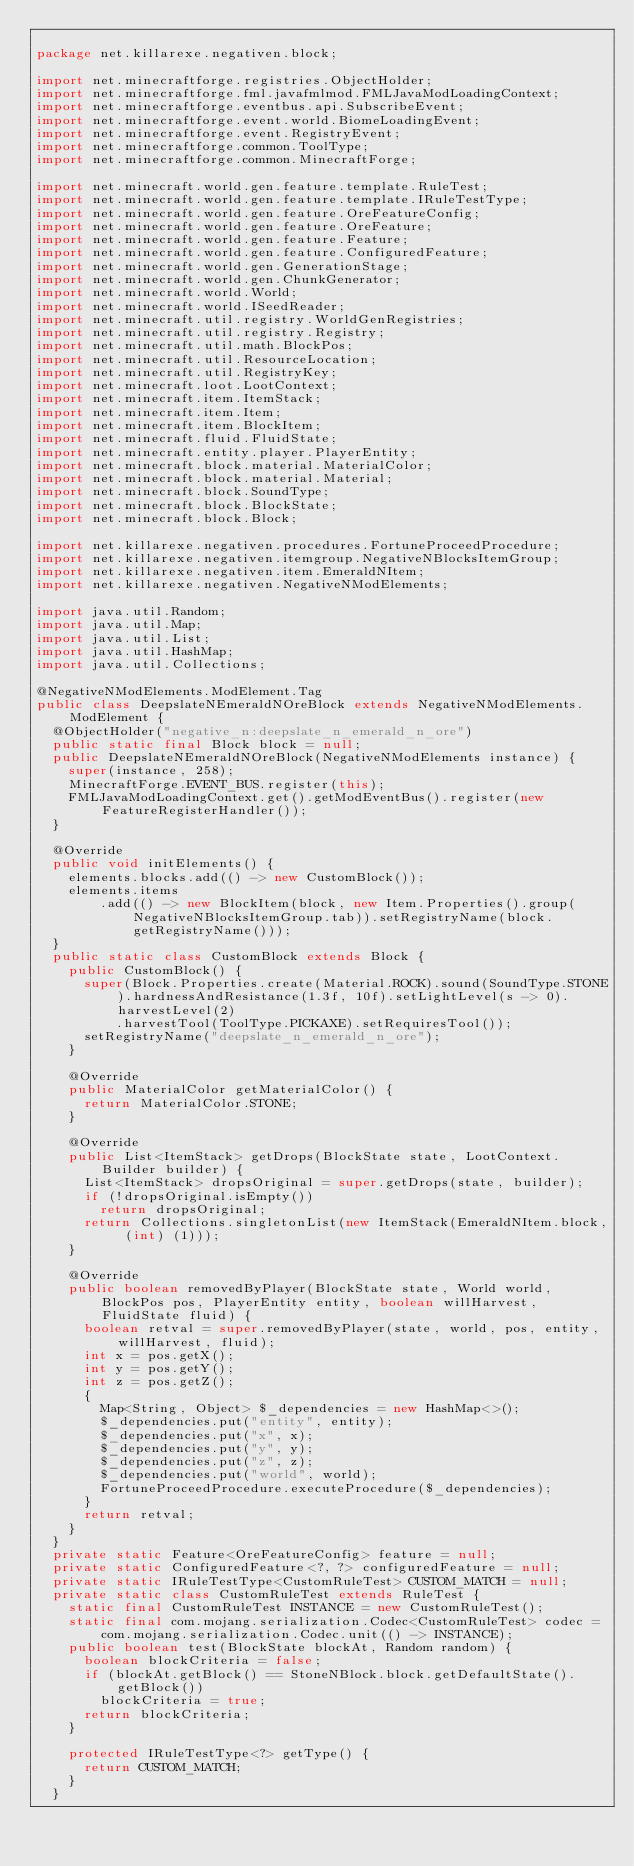<code> <loc_0><loc_0><loc_500><loc_500><_Java_>
package net.killarexe.negativen.block;

import net.minecraftforge.registries.ObjectHolder;
import net.minecraftforge.fml.javafmlmod.FMLJavaModLoadingContext;
import net.minecraftforge.eventbus.api.SubscribeEvent;
import net.minecraftforge.event.world.BiomeLoadingEvent;
import net.minecraftforge.event.RegistryEvent;
import net.minecraftforge.common.ToolType;
import net.minecraftforge.common.MinecraftForge;

import net.minecraft.world.gen.feature.template.RuleTest;
import net.minecraft.world.gen.feature.template.IRuleTestType;
import net.minecraft.world.gen.feature.OreFeatureConfig;
import net.minecraft.world.gen.feature.OreFeature;
import net.minecraft.world.gen.feature.Feature;
import net.minecraft.world.gen.feature.ConfiguredFeature;
import net.minecraft.world.gen.GenerationStage;
import net.minecraft.world.gen.ChunkGenerator;
import net.minecraft.world.World;
import net.minecraft.world.ISeedReader;
import net.minecraft.util.registry.WorldGenRegistries;
import net.minecraft.util.registry.Registry;
import net.minecraft.util.math.BlockPos;
import net.minecraft.util.ResourceLocation;
import net.minecraft.util.RegistryKey;
import net.minecraft.loot.LootContext;
import net.minecraft.item.ItemStack;
import net.minecraft.item.Item;
import net.minecraft.item.BlockItem;
import net.minecraft.fluid.FluidState;
import net.minecraft.entity.player.PlayerEntity;
import net.minecraft.block.material.MaterialColor;
import net.minecraft.block.material.Material;
import net.minecraft.block.SoundType;
import net.minecraft.block.BlockState;
import net.minecraft.block.Block;

import net.killarexe.negativen.procedures.FortuneProceedProcedure;
import net.killarexe.negativen.itemgroup.NegativeNBlocksItemGroup;
import net.killarexe.negativen.item.EmeraldNItem;
import net.killarexe.negativen.NegativeNModElements;

import java.util.Random;
import java.util.Map;
import java.util.List;
import java.util.HashMap;
import java.util.Collections;

@NegativeNModElements.ModElement.Tag
public class DeepslateNEmeraldNOreBlock extends NegativeNModElements.ModElement {
	@ObjectHolder("negative_n:deepslate_n_emerald_n_ore")
	public static final Block block = null;
	public DeepslateNEmeraldNOreBlock(NegativeNModElements instance) {
		super(instance, 258);
		MinecraftForge.EVENT_BUS.register(this);
		FMLJavaModLoadingContext.get().getModEventBus().register(new FeatureRegisterHandler());
	}

	@Override
	public void initElements() {
		elements.blocks.add(() -> new CustomBlock());
		elements.items
				.add(() -> new BlockItem(block, new Item.Properties().group(NegativeNBlocksItemGroup.tab)).setRegistryName(block.getRegistryName()));
	}
	public static class CustomBlock extends Block {
		public CustomBlock() {
			super(Block.Properties.create(Material.ROCK).sound(SoundType.STONE).hardnessAndResistance(1.3f, 10f).setLightLevel(s -> 0).harvestLevel(2)
					.harvestTool(ToolType.PICKAXE).setRequiresTool());
			setRegistryName("deepslate_n_emerald_n_ore");
		}

		@Override
		public MaterialColor getMaterialColor() {
			return MaterialColor.STONE;
		}

		@Override
		public List<ItemStack> getDrops(BlockState state, LootContext.Builder builder) {
			List<ItemStack> dropsOriginal = super.getDrops(state, builder);
			if (!dropsOriginal.isEmpty())
				return dropsOriginal;
			return Collections.singletonList(new ItemStack(EmeraldNItem.block, (int) (1)));
		}

		@Override
		public boolean removedByPlayer(BlockState state, World world, BlockPos pos, PlayerEntity entity, boolean willHarvest, FluidState fluid) {
			boolean retval = super.removedByPlayer(state, world, pos, entity, willHarvest, fluid);
			int x = pos.getX();
			int y = pos.getY();
			int z = pos.getZ();
			{
				Map<String, Object> $_dependencies = new HashMap<>();
				$_dependencies.put("entity", entity);
				$_dependencies.put("x", x);
				$_dependencies.put("y", y);
				$_dependencies.put("z", z);
				$_dependencies.put("world", world);
				FortuneProceedProcedure.executeProcedure($_dependencies);
			}
			return retval;
		}
	}
	private static Feature<OreFeatureConfig> feature = null;
	private static ConfiguredFeature<?, ?> configuredFeature = null;
	private static IRuleTestType<CustomRuleTest> CUSTOM_MATCH = null;
	private static class CustomRuleTest extends RuleTest {
		static final CustomRuleTest INSTANCE = new CustomRuleTest();
		static final com.mojang.serialization.Codec<CustomRuleTest> codec = com.mojang.serialization.Codec.unit(() -> INSTANCE);
		public boolean test(BlockState blockAt, Random random) {
			boolean blockCriteria = false;
			if (blockAt.getBlock() == StoneNBlock.block.getDefaultState().getBlock())
				blockCriteria = true;
			return blockCriteria;
		}

		protected IRuleTestType<?> getType() {
			return CUSTOM_MATCH;
		}
	}
</code> 